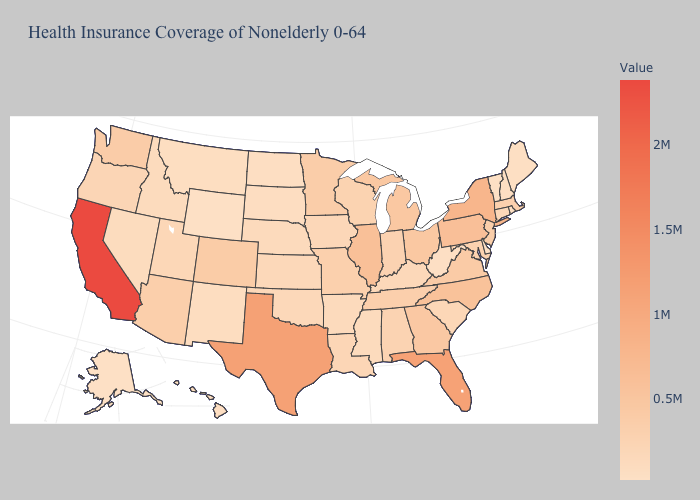Among the states that border Illinois , which have the highest value?
Give a very brief answer. Missouri. Does Alaska have the lowest value in the USA?
Keep it brief. Yes. 